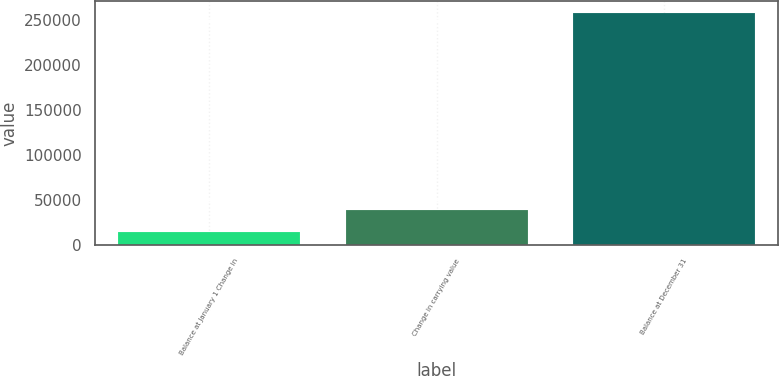Convert chart to OTSL. <chart><loc_0><loc_0><loc_500><loc_500><bar_chart><fcel>Balance at January 1 Change in<fcel>Change in carrying value<fcel>Balance at December 31<nl><fcel>14544<fcel>38917.6<fcel>258280<nl></chart> 